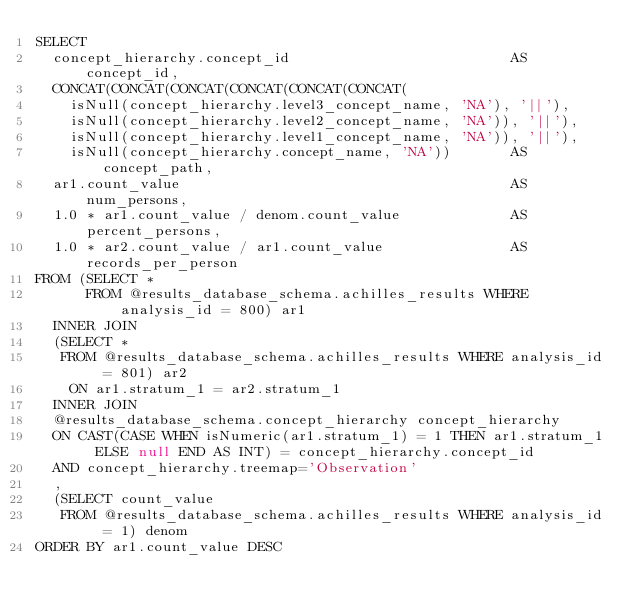Convert code to text. <code><loc_0><loc_0><loc_500><loc_500><_SQL_>SELECT
  concept_hierarchy.concept_id                          AS concept_id,
  CONCAT(CONCAT(CONCAT(CONCAT(CONCAT(CONCAT(
    isNull(concept_hierarchy.level3_concept_name, 'NA'), '||'),
    isNull(concept_hierarchy.level2_concept_name, 'NA')), '||'),
    isNull(concept_hierarchy.level1_concept_name, 'NA')), '||'),
    isNull(concept_hierarchy.concept_name, 'NA'))       AS concept_path,
  ar1.count_value                                       AS num_persons,
  1.0 * ar1.count_value / denom.count_value             AS percent_persons,
  1.0 * ar2.count_value / ar1.count_value               AS records_per_person
FROM (SELECT *
      FROM @results_database_schema.achilles_results WHERE analysis_id = 800) ar1
  INNER JOIN
  (SELECT *
   FROM @results_database_schema.achilles_results WHERE analysis_id = 801) ar2
    ON ar1.stratum_1 = ar2.stratum_1
  INNER JOIN
  @results_database_schema.concept_hierarchy concept_hierarchy
  ON CAST(CASE WHEN isNumeric(ar1.stratum_1) = 1 THEN ar1.stratum_1 ELSE null END AS INT) = concept_hierarchy.concept_id
  AND concept_hierarchy.treemap='Observation'
  ,
  (SELECT count_value
   FROM @results_database_schema.achilles_results WHERE analysis_id = 1) denom
ORDER BY ar1.count_value DESC
</code> 